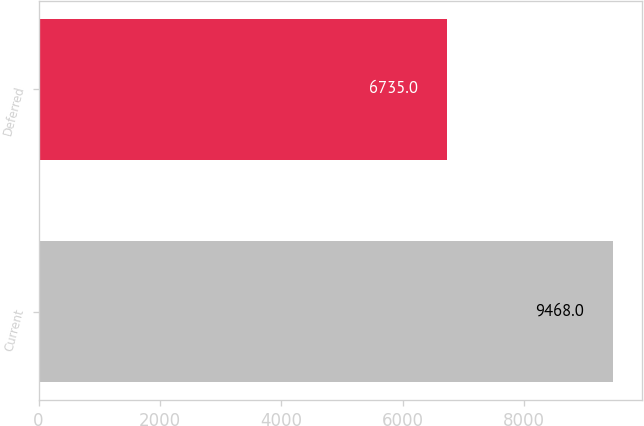Convert chart to OTSL. <chart><loc_0><loc_0><loc_500><loc_500><bar_chart><fcel>Current<fcel>Deferred<nl><fcel>9468<fcel>6735<nl></chart> 